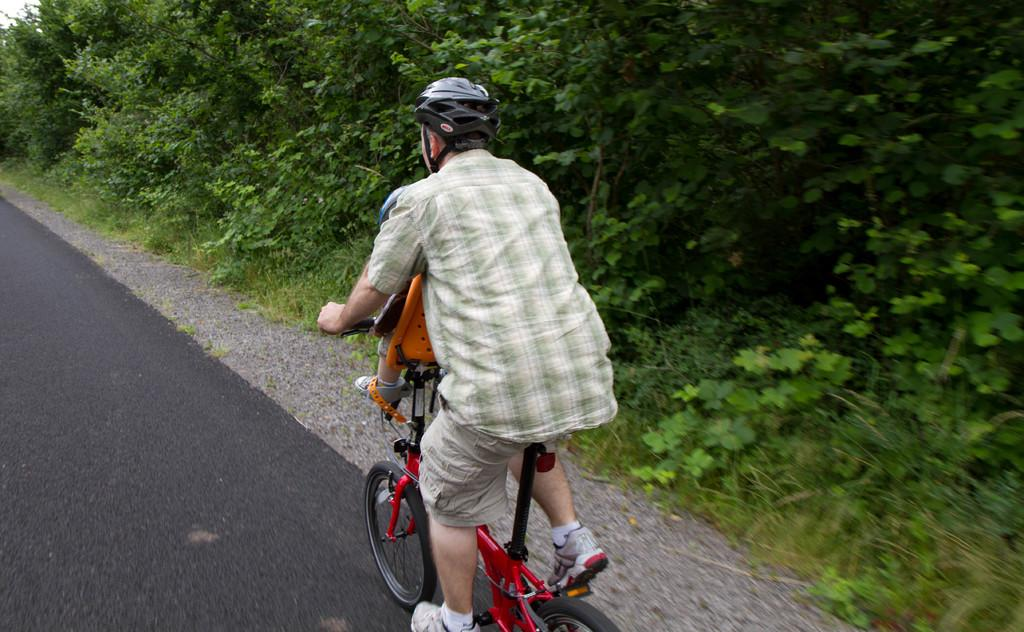Who is present in the image? There is a man and a kid in the image. What are the man and the kid doing in the image? Both the man and the kid are sitting on bicycles. What can be seen in the background of the image? There are trees in the background of the image. What is visible at the bottom of the image? There is a road visible at the bottom of the image. What type of scent can be smelled coming from the foot of the man in the image? There is no indication of any scent or foot in the image; it only shows a man and a kid sitting on bicycles with trees in the background and a road at the bottom. 